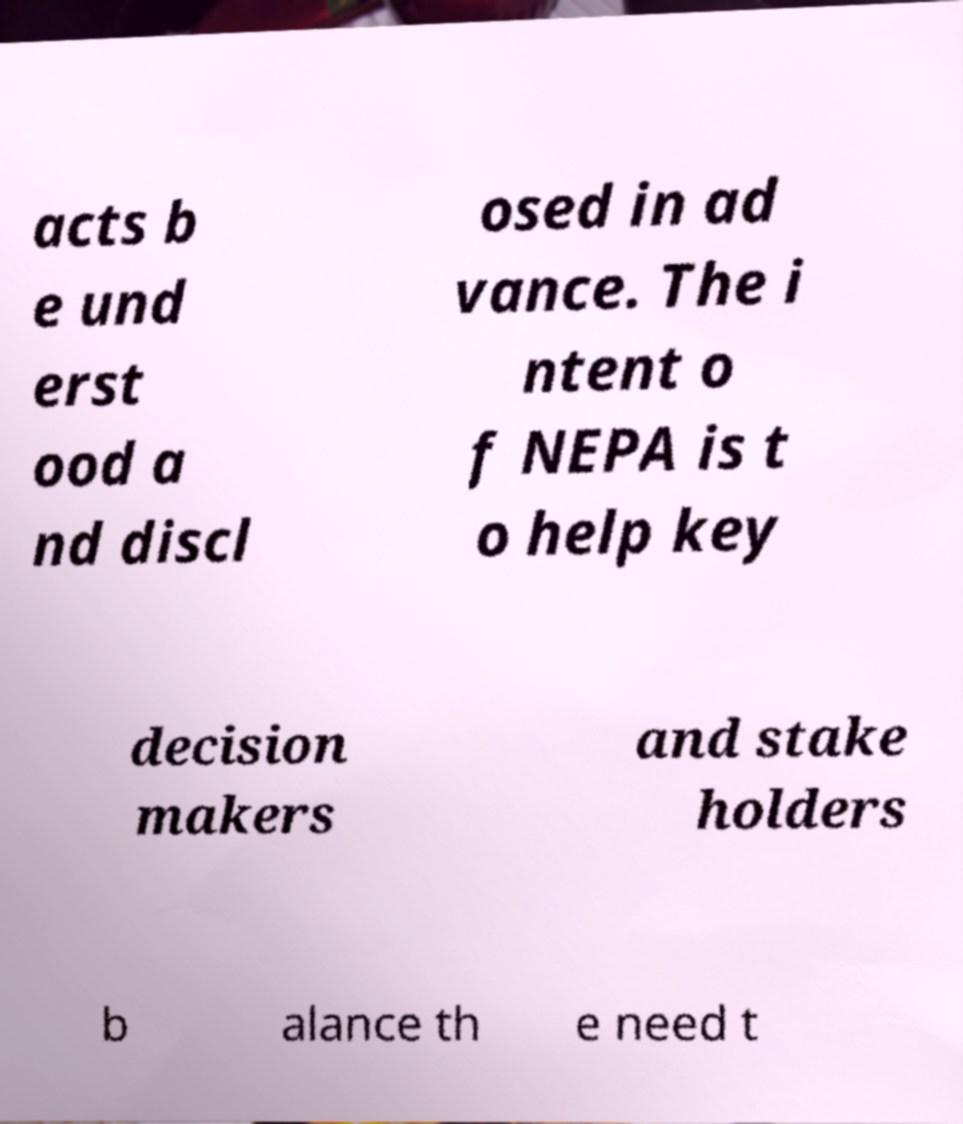Could you assist in decoding the text presented in this image and type it out clearly? acts b e und erst ood a nd discl osed in ad vance. The i ntent o f NEPA is t o help key decision makers and stake holders b alance th e need t 